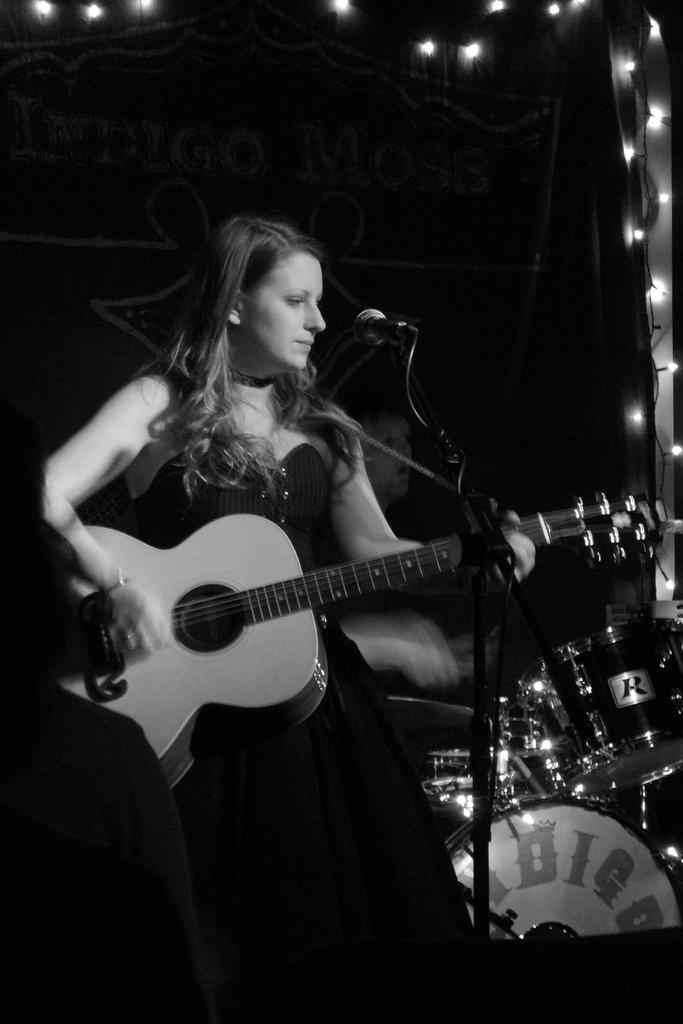What is the person in the image doing? The person is playing the guitar. What can be seen behind the person? The person is standing in front of a mic. What other musical instruments are visible in the image? There is a drum set to the left of the person. What type of jellyfish can be seen swimming in the background of the image? There are no jellyfish present in the image; it features a person playing the guitar in front of a mic with a drum set nearby. 